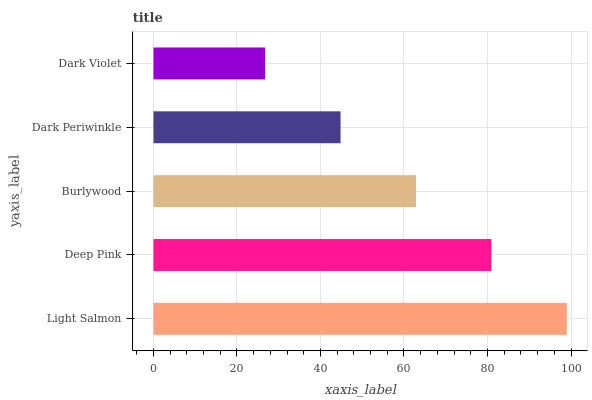Is Dark Violet the minimum?
Answer yes or no. Yes. Is Light Salmon the maximum?
Answer yes or no. Yes. Is Deep Pink the minimum?
Answer yes or no. No. Is Deep Pink the maximum?
Answer yes or no. No. Is Light Salmon greater than Deep Pink?
Answer yes or no. Yes. Is Deep Pink less than Light Salmon?
Answer yes or no. Yes. Is Deep Pink greater than Light Salmon?
Answer yes or no. No. Is Light Salmon less than Deep Pink?
Answer yes or no. No. Is Burlywood the high median?
Answer yes or no. Yes. Is Burlywood the low median?
Answer yes or no. Yes. Is Dark Periwinkle the high median?
Answer yes or no. No. Is Light Salmon the low median?
Answer yes or no. No. 